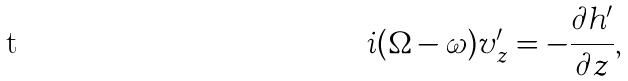Convert formula to latex. <formula><loc_0><loc_0><loc_500><loc_500>i ( \Omega - \omega ) v _ { z } ^ { \prime } = - \frac { \partial h ^ { \prime } } { \partial z } ,</formula> 